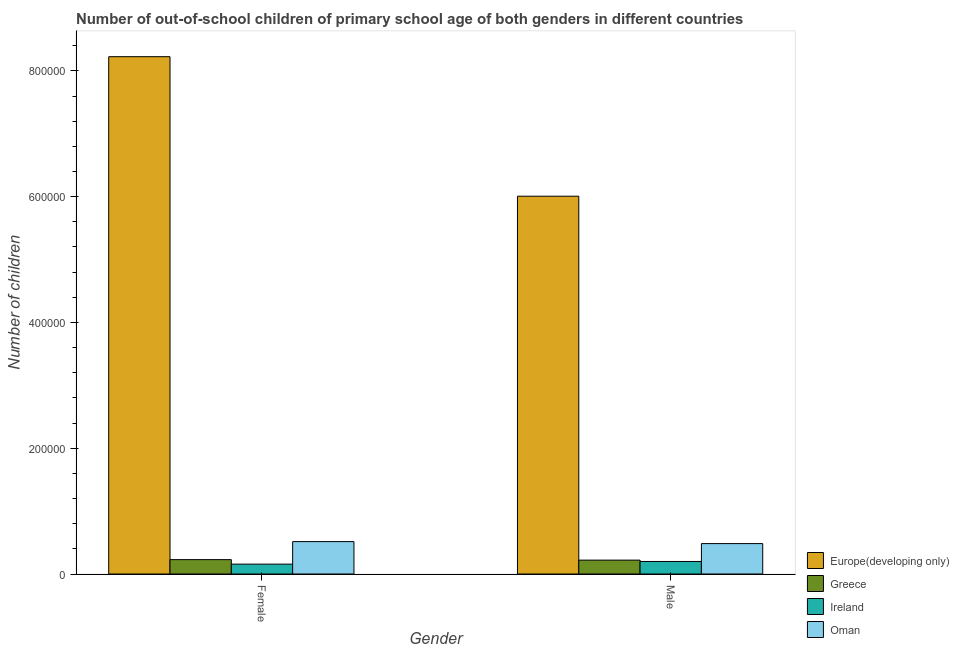How many groups of bars are there?
Ensure brevity in your answer.  2. Are the number of bars per tick equal to the number of legend labels?
Keep it short and to the point. Yes. How many bars are there on the 1st tick from the left?
Provide a succinct answer. 4. What is the number of male out-of-school students in Europe(developing only)?
Your answer should be very brief. 6.01e+05. Across all countries, what is the maximum number of female out-of-school students?
Your answer should be very brief. 8.23e+05. Across all countries, what is the minimum number of female out-of-school students?
Your answer should be compact. 1.57e+04. In which country was the number of female out-of-school students maximum?
Offer a very short reply. Europe(developing only). In which country was the number of male out-of-school students minimum?
Provide a short and direct response. Ireland. What is the total number of male out-of-school students in the graph?
Provide a short and direct response. 6.91e+05. What is the difference between the number of female out-of-school students in Oman and that in Europe(developing only)?
Offer a terse response. -7.71e+05. What is the difference between the number of male out-of-school students in Greece and the number of female out-of-school students in Oman?
Make the answer very short. -2.95e+04. What is the average number of male out-of-school students per country?
Offer a very short reply. 1.73e+05. What is the difference between the number of male out-of-school students and number of female out-of-school students in Greece?
Make the answer very short. -790. What is the ratio of the number of male out-of-school students in Europe(developing only) to that in Ireland?
Offer a terse response. 30.17. In how many countries, is the number of female out-of-school students greater than the average number of female out-of-school students taken over all countries?
Your answer should be compact. 1. What does the 3rd bar from the right in Female represents?
Make the answer very short. Greece. How many bars are there?
Make the answer very short. 8. Are all the bars in the graph horizontal?
Make the answer very short. No. How many countries are there in the graph?
Make the answer very short. 4. What is the difference between two consecutive major ticks on the Y-axis?
Your answer should be very brief. 2.00e+05. Where does the legend appear in the graph?
Provide a succinct answer. Bottom right. How are the legend labels stacked?
Provide a succinct answer. Vertical. What is the title of the graph?
Your answer should be compact. Number of out-of-school children of primary school age of both genders in different countries. Does "Guinea" appear as one of the legend labels in the graph?
Your answer should be very brief. No. What is the label or title of the X-axis?
Your response must be concise. Gender. What is the label or title of the Y-axis?
Offer a very short reply. Number of children. What is the Number of children of Europe(developing only) in Female?
Offer a terse response. 8.23e+05. What is the Number of children of Greece in Female?
Provide a short and direct response. 2.28e+04. What is the Number of children in Ireland in Female?
Your answer should be compact. 1.57e+04. What is the Number of children of Oman in Female?
Your response must be concise. 5.15e+04. What is the Number of children of Europe(developing only) in Male?
Give a very brief answer. 6.01e+05. What is the Number of children of Greece in Male?
Give a very brief answer. 2.21e+04. What is the Number of children in Ireland in Male?
Offer a very short reply. 1.99e+04. What is the Number of children of Oman in Male?
Offer a terse response. 4.83e+04. Across all Gender, what is the maximum Number of children in Europe(developing only)?
Your answer should be compact. 8.23e+05. Across all Gender, what is the maximum Number of children in Greece?
Provide a succinct answer. 2.28e+04. Across all Gender, what is the maximum Number of children in Ireland?
Offer a very short reply. 1.99e+04. Across all Gender, what is the maximum Number of children of Oman?
Ensure brevity in your answer.  5.15e+04. Across all Gender, what is the minimum Number of children of Europe(developing only)?
Offer a terse response. 6.01e+05. Across all Gender, what is the minimum Number of children in Greece?
Make the answer very short. 2.21e+04. Across all Gender, what is the minimum Number of children of Ireland?
Your answer should be compact. 1.57e+04. Across all Gender, what is the minimum Number of children of Oman?
Make the answer very short. 4.83e+04. What is the total Number of children of Europe(developing only) in the graph?
Provide a short and direct response. 1.42e+06. What is the total Number of children of Greece in the graph?
Offer a very short reply. 4.49e+04. What is the total Number of children of Ireland in the graph?
Give a very brief answer. 3.56e+04. What is the total Number of children of Oman in the graph?
Ensure brevity in your answer.  9.99e+04. What is the difference between the Number of children in Europe(developing only) in Female and that in Male?
Your answer should be very brief. 2.22e+05. What is the difference between the Number of children of Greece in Female and that in Male?
Ensure brevity in your answer.  790. What is the difference between the Number of children of Ireland in Female and that in Male?
Give a very brief answer. -4191. What is the difference between the Number of children in Oman in Female and that in Male?
Give a very brief answer. 3181. What is the difference between the Number of children in Europe(developing only) in Female and the Number of children in Greece in Male?
Offer a terse response. 8.00e+05. What is the difference between the Number of children in Europe(developing only) in Female and the Number of children in Ireland in Male?
Give a very brief answer. 8.03e+05. What is the difference between the Number of children of Europe(developing only) in Female and the Number of children of Oman in Male?
Provide a succinct answer. 7.74e+05. What is the difference between the Number of children of Greece in Female and the Number of children of Ireland in Male?
Your response must be concise. 2934. What is the difference between the Number of children in Greece in Female and the Number of children in Oman in Male?
Offer a very short reply. -2.55e+04. What is the difference between the Number of children of Ireland in Female and the Number of children of Oman in Male?
Offer a very short reply. -3.26e+04. What is the average Number of children of Europe(developing only) per Gender?
Give a very brief answer. 7.12e+05. What is the average Number of children of Greece per Gender?
Provide a succinct answer. 2.24e+04. What is the average Number of children in Ireland per Gender?
Provide a short and direct response. 1.78e+04. What is the average Number of children in Oman per Gender?
Give a very brief answer. 4.99e+04. What is the difference between the Number of children in Europe(developing only) and Number of children in Greece in Female?
Ensure brevity in your answer.  8.00e+05. What is the difference between the Number of children of Europe(developing only) and Number of children of Ireland in Female?
Your answer should be compact. 8.07e+05. What is the difference between the Number of children of Europe(developing only) and Number of children of Oman in Female?
Provide a succinct answer. 7.71e+05. What is the difference between the Number of children in Greece and Number of children in Ireland in Female?
Ensure brevity in your answer.  7125. What is the difference between the Number of children in Greece and Number of children in Oman in Female?
Give a very brief answer. -2.87e+04. What is the difference between the Number of children of Ireland and Number of children of Oman in Female?
Your answer should be very brief. -3.58e+04. What is the difference between the Number of children of Europe(developing only) and Number of children of Greece in Male?
Your answer should be compact. 5.79e+05. What is the difference between the Number of children of Europe(developing only) and Number of children of Ireland in Male?
Offer a very short reply. 5.81e+05. What is the difference between the Number of children in Europe(developing only) and Number of children in Oman in Male?
Offer a terse response. 5.52e+05. What is the difference between the Number of children of Greece and Number of children of Ireland in Male?
Provide a succinct answer. 2144. What is the difference between the Number of children of Greece and Number of children of Oman in Male?
Give a very brief answer. -2.63e+04. What is the difference between the Number of children in Ireland and Number of children in Oman in Male?
Provide a succinct answer. -2.84e+04. What is the ratio of the Number of children of Europe(developing only) in Female to that in Male?
Provide a succinct answer. 1.37. What is the ratio of the Number of children of Greece in Female to that in Male?
Give a very brief answer. 1.04. What is the ratio of the Number of children in Ireland in Female to that in Male?
Your answer should be compact. 0.79. What is the ratio of the Number of children in Oman in Female to that in Male?
Keep it short and to the point. 1.07. What is the difference between the highest and the second highest Number of children of Europe(developing only)?
Your answer should be compact. 2.22e+05. What is the difference between the highest and the second highest Number of children in Greece?
Give a very brief answer. 790. What is the difference between the highest and the second highest Number of children of Ireland?
Offer a very short reply. 4191. What is the difference between the highest and the second highest Number of children of Oman?
Provide a short and direct response. 3181. What is the difference between the highest and the lowest Number of children of Europe(developing only)?
Provide a succinct answer. 2.22e+05. What is the difference between the highest and the lowest Number of children in Greece?
Provide a succinct answer. 790. What is the difference between the highest and the lowest Number of children in Ireland?
Your answer should be very brief. 4191. What is the difference between the highest and the lowest Number of children of Oman?
Keep it short and to the point. 3181. 